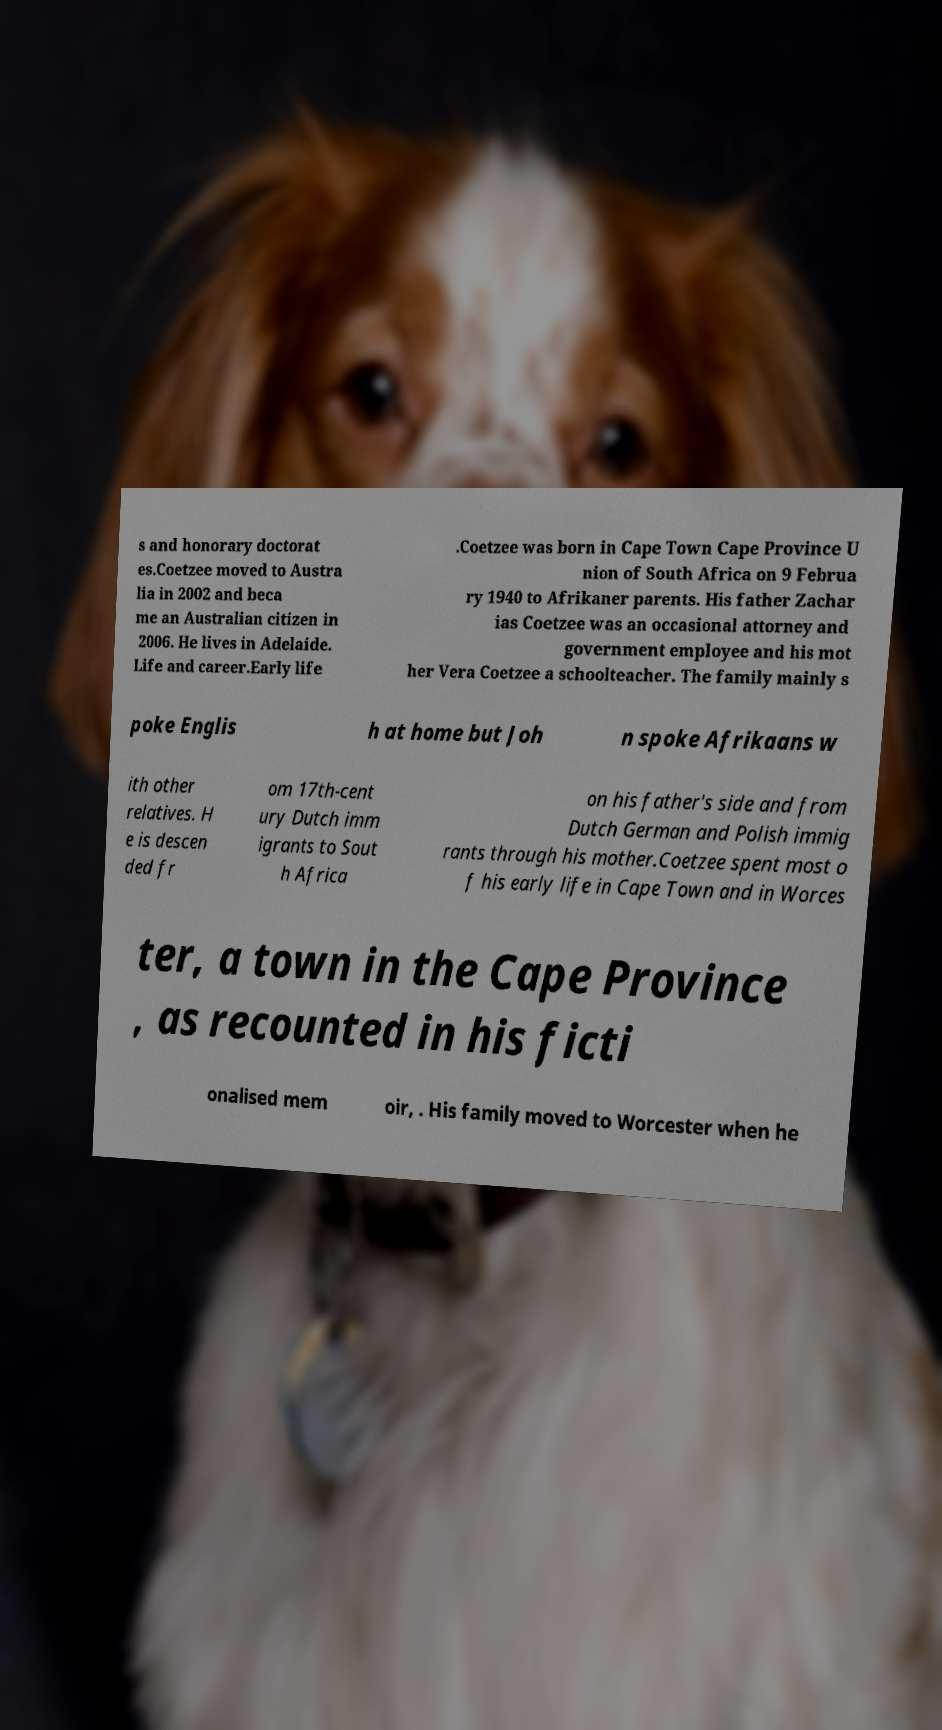What messages or text are displayed in this image? I need them in a readable, typed format. s and honorary doctorat es.Coetzee moved to Austra lia in 2002 and beca me an Australian citizen in 2006. He lives in Adelaide. Life and career.Early life .Coetzee was born in Cape Town Cape Province U nion of South Africa on 9 Februa ry 1940 to Afrikaner parents. His father Zachar ias Coetzee was an occasional attorney and government employee and his mot her Vera Coetzee a schoolteacher. The family mainly s poke Englis h at home but Joh n spoke Afrikaans w ith other relatives. H e is descen ded fr om 17th-cent ury Dutch imm igrants to Sout h Africa on his father's side and from Dutch German and Polish immig rants through his mother.Coetzee spent most o f his early life in Cape Town and in Worces ter, a town in the Cape Province , as recounted in his ficti onalised mem oir, . His family moved to Worcester when he 